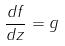Convert formula to latex. <formula><loc_0><loc_0><loc_500><loc_500>\frac { d f } { d z } = g</formula> 